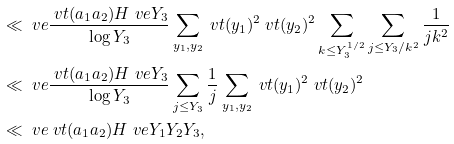<formula> <loc_0><loc_0><loc_500><loc_500>& \ll _ { \ } v e \frac { \ v t ( a _ { 1 } a _ { 2 } ) H ^ { \ } v e Y _ { 3 } } { \log Y _ { 3 } } \sum _ { y _ { 1 } , y _ { 2 } } \ v t ( y _ { 1 } ) ^ { 2 } \ v t ( y _ { 2 } ) ^ { 2 } \sum _ { k \leq Y _ { 3 } ^ { 1 / 2 } } \sum _ { j \leq Y _ { 3 } / k ^ { 2 } } \frac { 1 } { j k ^ { 2 } } \\ & \ll _ { \ } v e \frac { \ v t ( a _ { 1 } a _ { 2 } ) H ^ { \ } v e Y _ { 3 } } { \log Y _ { 3 } } \sum _ { j \leq Y _ { 3 } } \frac { 1 } { j } \sum _ { y _ { 1 } , y _ { 2 } } \ v t ( y _ { 1 } ) ^ { 2 } \ v t ( y _ { 2 } ) ^ { 2 } \\ & \ll _ { \ } v e \ v t ( a _ { 1 } a _ { 2 } ) H ^ { \ } v e Y _ { 1 } Y _ { 2 } Y _ { 3 } ,</formula> 